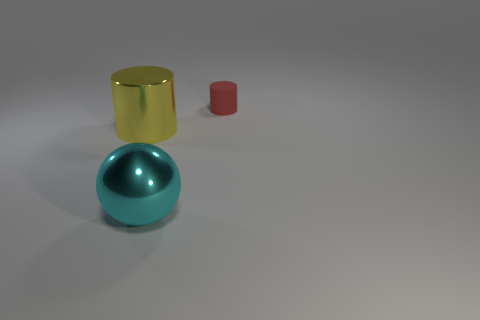What objects are visible in the image, and what are their colors? The image presents three distinct objects: a glossy cyan-colored metal sphere, a reflective gold cylinder slightly taller than the sphere, and a smaller matte red cylinder. 